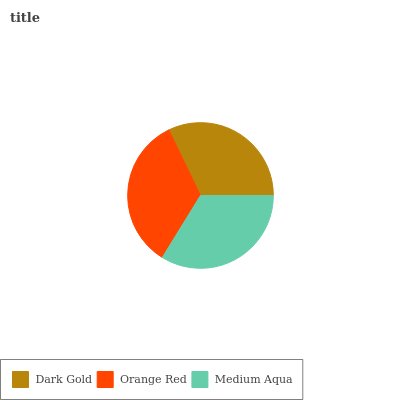Is Dark Gold the minimum?
Answer yes or no. Yes. Is Orange Red the maximum?
Answer yes or no. Yes. Is Medium Aqua the minimum?
Answer yes or no. No. Is Medium Aqua the maximum?
Answer yes or no. No. Is Orange Red greater than Medium Aqua?
Answer yes or no. Yes. Is Medium Aqua less than Orange Red?
Answer yes or no. Yes. Is Medium Aqua greater than Orange Red?
Answer yes or no. No. Is Orange Red less than Medium Aqua?
Answer yes or no. No. Is Medium Aqua the high median?
Answer yes or no. Yes. Is Medium Aqua the low median?
Answer yes or no. Yes. Is Dark Gold the high median?
Answer yes or no. No. Is Dark Gold the low median?
Answer yes or no. No. 